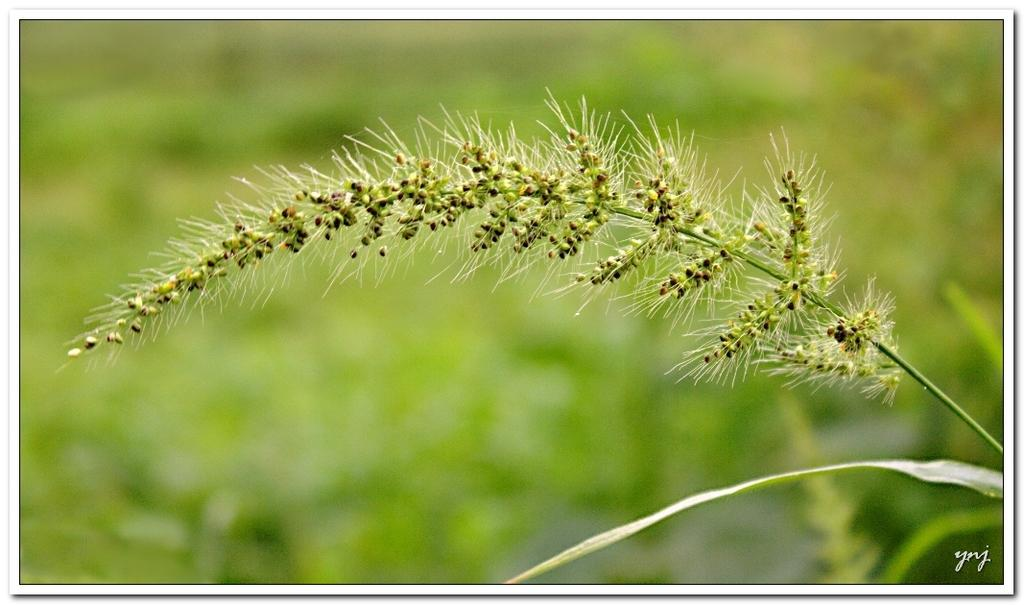What is the main subject of the image? The main subject of the image is a stem with grains. What can be seen on the stem? There is white hair on the stem. What other plant part is visible in the image? There is a leaf in the image. How would you describe the background of the image? The background is green and blurred. Is there any additional information or marking in the image? Yes, there is a watermark in the right bottom corner of the image. What type of bird can be seen perched on the stem in the image? There is no bird present in the image; it features a stem with grains, white hair, and a leaf. What disease is affecting the stem in the image? There is no indication of any disease affecting the stem in the image. 